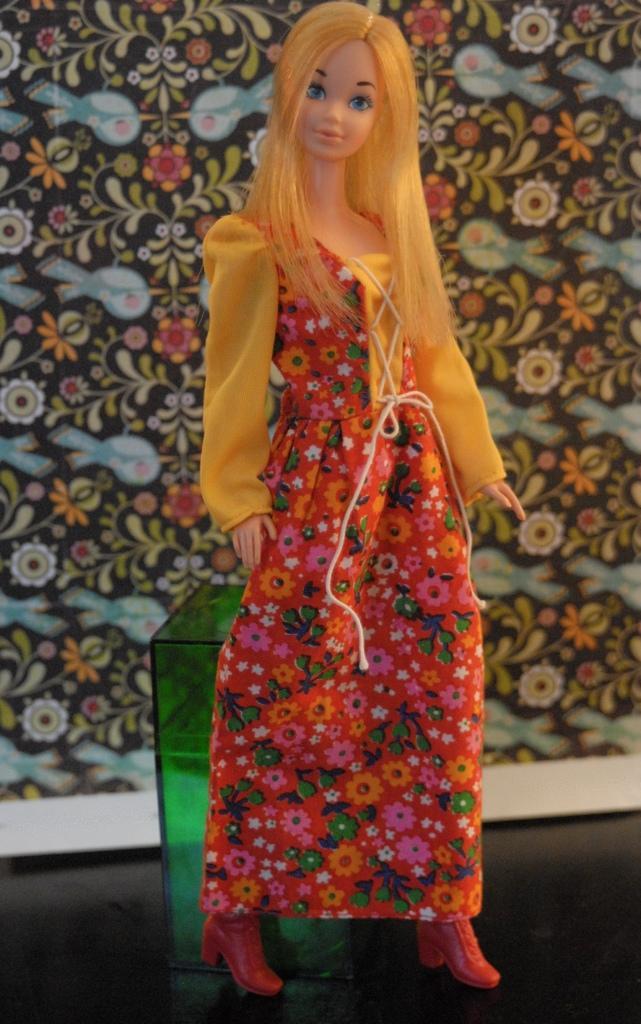In one or two sentences, can you explain what this image depicts? In this image, there is a doll in front of the box. There is a design behind the doll. 